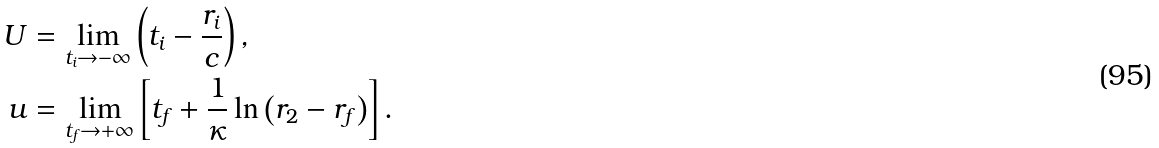Convert formula to latex. <formula><loc_0><loc_0><loc_500><loc_500>U & = \lim _ { t _ { i } \to - \infty } \left ( t _ { i } - \frac { r _ { i } } { c } \right ) , \\ u & = \lim _ { t _ { f } \to + \infty } \left [ t _ { f } + \frac { 1 } { \kappa } \ln \left ( r _ { 2 } - r _ { f } \right ) \right ] .</formula> 